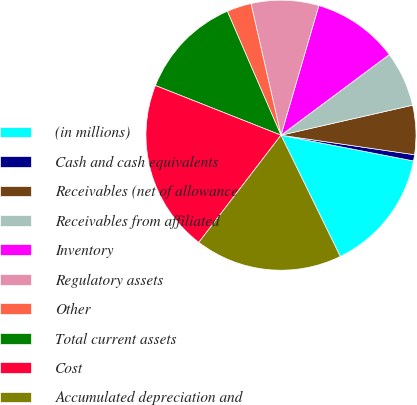Convert chart to OTSL. <chart><loc_0><loc_0><loc_500><loc_500><pie_chart><fcel>(in millions)<fcel>Cash and cash equivalents<fcel>Receivables (net of allowance<fcel>Receivables from affiliated<fcel>Inventory<fcel>Regulatory assets<fcel>Other<fcel>Total current assets<fcel>Cost<fcel>Accumulated depreciation and<nl><fcel>14.71%<fcel>0.74%<fcel>5.88%<fcel>6.62%<fcel>10.29%<fcel>8.09%<fcel>2.94%<fcel>12.5%<fcel>20.59%<fcel>17.65%<nl></chart> 